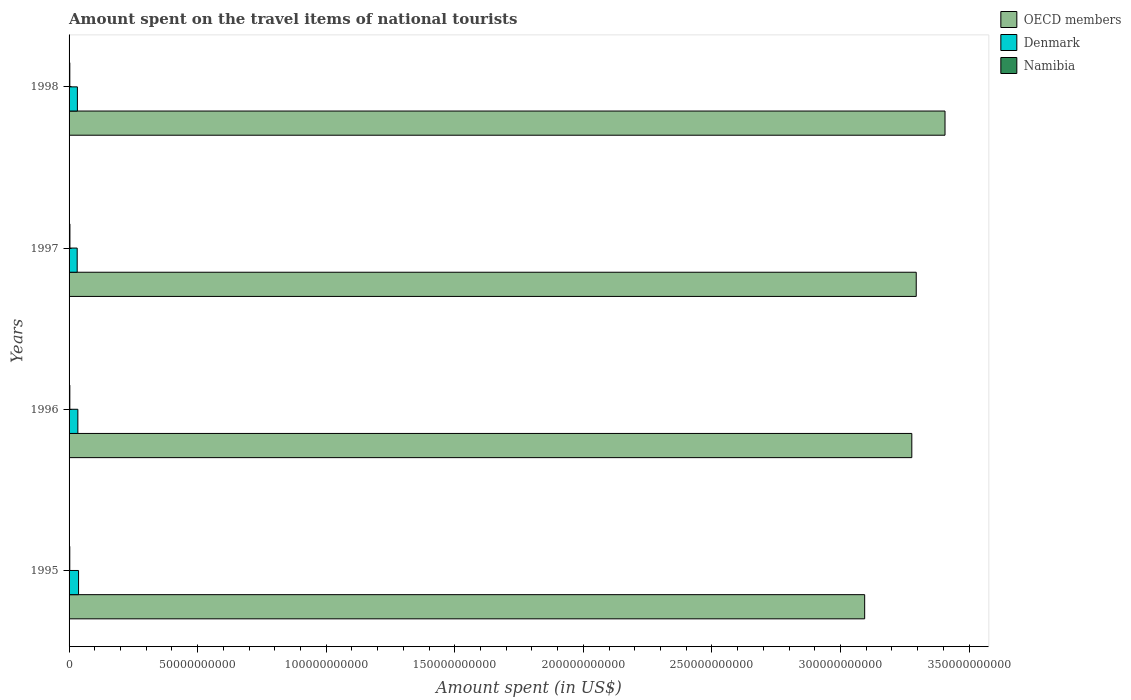How many groups of bars are there?
Your answer should be very brief. 4. What is the label of the 2nd group of bars from the top?
Provide a short and direct response. 1997. What is the amount spent on the travel items of national tourists in Namibia in 1997?
Offer a terse response. 3.33e+08. Across all years, what is the maximum amount spent on the travel items of national tourists in OECD members?
Provide a succinct answer. 3.41e+11. Across all years, what is the minimum amount spent on the travel items of national tourists in Namibia?
Offer a very short reply. 2.78e+08. In which year was the amount spent on the travel items of national tourists in Namibia maximum?
Give a very brief answer. 1997. In which year was the amount spent on the travel items of national tourists in OECD members minimum?
Provide a succinct answer. 1995. What is the total amount spent on the travel items of national tourists in Namibia in the graph?
Your answer should be compact. 1.19e+09. What is the difference between the amount spent on the travel items of national tourists in Denmark in 1996 and that in 1997?
Make the answer very short. 2.64e+08. What is the difference between the amount spent on the travel items of national tourists in OECD members in 1997 and the amount spent on the travel items of national tourists in Denmark in 1998?
Offer a terse response. 3.26e+11. What is the average amount spent on the travel items of national tourists in Denmark per year?
Provide a short and direct response. 3.38e+09. In the year 1997, what is the difference between the amount spent on the travel items of national tourists in OECD members and amount spent on the travel items of national tourists in Denmark?
Offer a terse response. 3.26e+11. In how many years, is the amount spent on the travel items of national tourists in Namibia greater than 300000000000 US$?
Offer a terse response. 0. What is the ratio of the amount spent on the travel items of national tourists in Denmark in 1996 to that in 1997?
Your answer should be compact. 1.08. Is the amount spent on the travel items of national tourists in Namibia in 1995 less than that in 1998?
Keep it short and to the point. Yes. What is the difference between the highest and the second highest amount spent on the travel items of national tourists in Denmark?
Offer a very short reply. 2.71e+08. What is the difference between the highest and the lowest amount spent on the travel items of national tourists in Namibia?
Ensure brevity in your answer.  5.50e+07. In how many years, is the amount spent on the travel items of national tourists in OECD members greater than the average amount spent on the travel items of national tourists in OECD members taken over all years?
Offer a very short reply. 3. Is the sum of the amount spent on the travel items of national tourists in OECD members in 1995 and 1998 greater than the maximum amount spent on the travel items of national tourists in Namibia across all years?
Offer a very short reply. Yes. What does the 1st bar from the bottom in 1995 represents?
Provide a short and direct response. OECD members. Is it the case that in every year, the sum of the amount spent on the travel items of national tourists in OECD members and amount spent on the travel items of national tourists in Denmark is greater than the amount spent on the travel items of national tourists in Namibia?
Your response must be concise. Yes. How many bars are there?
Your answer should be very brief. 12. How many years are there in the graph?
Make the answer very short. 4. Are the values on the major ticks of X-axis written in scientific E-notation?
Provide a short and direct response. No. Does the graph contain any zero values?
Offer a very short reply. No. Does the graph contain grids?
Give a very brief answer. No. How many legend labels are there?
Make the answer very short. 3. How are the legend labels stacked?
Offer a very short reply. Vertical. What is the title of the graph?
Your response must be concise. Amount spent on the travel items of national tourists. What is the label or title of the X-axis?
Your answer should be very brief. Amount spent (in US$). What is the Amount spent (in US$) of OECD members in 1995?
Provide a succinct answer. 3.09e+11. What is the Amount spent (in US$) of Denmark in 1995?
Provide a succinct answer. 3.69e+09. What is the Amount spent (in US$) in Namibia in 1995?
Your response must be concise. 2.78e+08. What is the Amount spent (in US$) of OECD members in 1996?
Ensure brevity in your answer.  3.28e+11. What is the Amount spent (in US$) in Denmark in 1996?
Your answer should be compact. 3.42e+09. What is the Amount spent (in US$) in Namibia in 1996?
Make the answer very short. 2.93e+08. What is the Amount spent (in US$) of OECD members in 1997?
Offer a very short reply. 3.29e+11. What is the Amount spent (in US$) in Denmark in 1997?
Your answer should be very brief. 3.16e+09. What is the Amount spent (in US$) in Namibia in 1997?
Offer a terse response. 3.33e+08. What is the Amount spent (in US$) of OECD members in 1998?
Your response must be concise. 3.41e+11. What is the Amount spent (in US$) in Denmark in 1998?
Make the answer very short. 3.24e+09. What is the Amount spent (in US$) in Namibia in 1998?
Your answer should be very brief. 2.88e+08. Across all years, what is the maximum Amount spent (in US$) in OECD members?
Offer a very short reply. 3.41e+11. Across all years, what is the maximum Amount spent (in US$) in Denmark?
Provide a short and direct response. 3.69e+09. Across all years, what is the maximum Amount spent (in US$) of Namibia?
Provide a succinct answer. 3.33e+08. Across all years, what is the minimum Amount spent (in US$) in OECD members?
Give a very brief answer. 3.09e+11. Across all years, what is the minimum Amount spent (in US$) in Denmark?
Your answer should be compact. 3.16e+09. Across all years, what is the minimum Amount spent (in US$) of Namibia?
Make the answer very short. 2.78e+08. What is the total Amount spent (in US$) in OECD members in the graph?
Keep it short and to the point. 1.31e+12. What is the total Amount spent (in US$) of Denmark in the graph?
Make the answer very short. 1.35e+1. What is the total Amount spent (in US$) of Namibia in the graph?
Your answer should be compact. 1.19e+09. What is the difference between the Amount spent (in US$) of OECD members in 1995 and that in 1996?
Offer a terse response. -1.83e+1. What is the difference between the Amount spent (in US$) of Denmark in 1995 and that in 1996?
Offer a terse response. 2.71e+08. What is the difference between the Amount spent (in US$) in Namibia in 1995 and that in 1996?
Offer a terse response. -1.50e+07. What is the difference between the Amount spent (in US$) in OECD members in 1995 and that in 1997?
Your answer should be very brief. -2.01e+1. What is the difference between the Amount spent (in US$) in Denmark in 1995 and that in 1997?
Your answer should be very brief. 5.35e+08. What is the difference between the Amount spent (in US$) in Namibia in 1995 and that in 1997?
Your answer should be compact. -5.50e+07. What is the difference between the Amount spent (in US$) in OECD members in 1995 and that in 1998?
Your answer should be very brief. -3.12e+1. What is the difference between the Amount spent (in US$) of Denmark in 1995 and that in 1998?
Your answer should be very brief. 4.55e+08. What is the difference between the Amount spent (in US$) of Namibia in 1995 and that in 1998?
Offer a terse response. -1.00e+07. What is the difference between the Amount spent (in US$) in OECD members in 1996 and that in 1997?
Keep it short and to the point. -1.72e+09. What is the difference between the Amount spent (in US$) in Denmark in 1996 and that in 1997?
Give a very brief answer. 2.64e+08. What is the difference between the Amount spent (in US$) in Namibia in 1996 and that in 1997?
Provide a succinct answer. -4.00e+07. What is the difference between the Amount spent (in US$) of OECD members in 1996 and that in 1998?
Your answer should be very brief. -1.29e+1. What is the difference between the Amount spent (in US$) in Denmark in 1996 and that in 1998?
Offer a very short reply. 1.84e+08. What is the difference between the Amount spent (in US$) of OECD members in 1997 and that in 1998?
Give a very brief answer. -1.12e+1. What is the difference between the Amount spent (in US$) of Denmark in 1997 and that in 1998?
Offer a very short reply. -8.00e+07. What is the difference between the Amount spent (in US$) of Namibia in 1997 and that in 1998?
Give a very brief answer. 4.50e+07. What is the difference between the Amount spent (in US$) in OECD members in 1995 and the Amount spent (in US$) in Denmark in 1996?
Provide a succinct answer. 3.06e+11. What is the difference between the Amount spent (in US$) in OECD members in 1995 and the Amount spent (in US$) in Namibia in 1996?
Your answer should be very brief. 3.09e+11. What is the difference between the Amount spent (in US$) in Denmark in 1995 and the Amount spent (in US$) in Namibia in 1996?
Your response must be concise. 3.40e+09. What is the difference between the Amount spent (in US$) in OECD members in 1995 and the Amount spent (in US$) in Denmark in 1997?
Your answer should be very brief. 3.06e+11. What is the difference between the Amount spent (in US$) in OECD members in 1995 and the Amount spent (in US$) in Namibia in 1997?
Keep it short and to the point. 3.09e+11. What is the difference between the Amount spent (in US$) of Denmark in 1995 and the Amount spent (in US$) of Namibia in 1997?
Ensure brevity in your answer.  3.36e+09. What is the difference between the Amount spent (in US$) of OECD members in 1995 and the Amount spent (in US$) of Denmark in 1998?
Make the answer very short. 3.06e+11. What is the difference between the Amount spent (in US$) in OECD members in 1995 and the Amount spent (in US$) in Namibia in 1998?
Provide a succinct answer. 3.09e+11. What is the difference between the Amount spent (in US$) of Denmark in 1995 and the Amount spent (in US$) of Namibia in 1998?
Provide a succinct answer. 3.40e+09. What is the difference between the Amount spent (in US$) in OECD members in 1996 and the Amount spent (in US$) in Denmark in 1997?
Your answer should be very brief. 3.25e+11. What is the difference between the Amount spent (in US$) in OECD members in 1996 and the Amount spent (in US$) in Namibia in 1997?
Provide a succinct answer. 3.27e+11. What is the difference between the Amount spent (in US$) of Denmark in 1996 and the Amount spent (in US$) of Namibia in 1997?
Make the answer very short. 3.09e+09. What is the difference between the Amount spent (in US$) in OECD members in 1996 and the Amount spent (in US$) in Denmark in 1998?
Provide a succinct answer. 3.25e+11. What is the difference between the Amount spent (in US$) in OECD members in 1996 and the Amount spent (in US$) in Namibia in 1998?
Ensure brevity in your answer.  3.27e+11. What is the difference between the Amount spent (in US$) of Denmark in 1996 and the Amount spent (in US$) of Namibia in 1998?
Provide a succinct answer. 3.13e+09. What is the difference between the Amount spent (in US$) in OECD members in 1997 and the Amount spent (in US$) in Denmark in 1998?
Ensure brevity in your answer.  3.26e+11. What is the difference between the Amount spent (in US$) in OECD members in 1997 and the Amount spent (in US$) in Namibia in 1998?
Provide a short and direct response. 3.29e+11. What is the difference between the Amount spent (in US$) of Denmark in 1997 and the Amount spent (in US$) of Namibia in 1998?
Provide a short and direct response. 2.87e+09. What is the average Amount spent (in US$) in OECD members per year?
Offer a very short reply. 3.27e+11. What is the average Amount spent (in US$) of Denmark per year?
Your answer should be very brief. 3.38e+09. What is the average Amount spent (in US$) in Namibia per year?
Give a very brief answer. 2.98e+08. In the year 1995, what is the difference between the Amount spent (in US$) of OECD members and Amount spent (in US$) of Denmark?
Provide a short and direct response. 3.06e+11. In the year 1995, what is the difference between the Amount spent (in US$) of OECD members and Amount spent (in US$) of Namibia?
Offer a very short reply. 3.09e+11. In the year 1995, what is the difference between the Amount spent (in US$) in Denmark and Amount spent (in US$) in Namibia?
Your answer should be compact. 3.41e+09. In the year 1996, what is the difference between the Amount spent (in US$) of OECD members and Amount spent (in US$) of Denmark?
Provide a short and direct response. 3.24e+11. In the year 1996, what is the difference between the Amount spent (in US$) of OECD members and Amount spent (in US$) of Namibia?
Offer a very short reply. 3.27e+11. In the year 1996, what is the difference between the Amount spent (in US$) of Denmark and Amount spent (in US$) of Namibia?
Make the answer very short. 3.13e+09. In the year 1997, what is the difference between the Amount spent (in US$) of OECD members and Amount spent (in US$) of Denmark?
Your answer should be compact. 3.26e+11. In the year 1997, what is the difference between the Amount spent (in US$) of OECD members and Amount spent (in US$) of Namibia?
Offer a very short reply. 3.29e+11. In the year 1997, what is the difference between the Amount spent (in US$) in Denmark and Amount spent (in US$) in Namibia?
Keep it short and to the point. 2.82e+09. In the year 1998, what is the difference between the Amount spent (in US$) in OECD members and Amount spent (in US$) in Denmark?
Your answer should be compact. 3.37e+11. In the year 1998, what is the difference between the Amount spent (in US$) of OECD members and Amount spent (in US$) of Namibia?
Your answer should be compact. 3.40e+11. In the year 1998, what is the difference between the Amount spent (in US$) of Denmark and Amount spent (in US$) of Namibia?
Your answer should be compact. 2.95e+09. What is the ratio of the Amount spent (in US$) in OECD members in 1995 to that in 1996?
Provide a succinct answer. 0.94. What is the ratio of the Amount spent (in US$) of Denmark in 1995 to that in 1996?
Ensure brevity in your answer.  1.08. What is the ratio of the Amount spent (in US$) in Namibia in 1995 to that in 1996?
Provide a succinct answer. 0.95. What is the ratio of the Amount spent (in US$) of OECD members in 1995 to that in 1997?
Provide a succinct answer. 0.94. What is the ratio of the Amount spent (in US$) in Denmark in 1995 to that in 1997?
Give a very brief answer. 1.17. What is the ratio of the Amount spent (in US$) of Namibia in 1995 to that in 1997?
Provide a succinct answer. 0.83. What is the ratio of the Amount spent (in US$) of OECD members in 1995 to that in 1998?
Provide a succinct answer. 0.91. What is the ratio of the Amount spent (in US$) in Denmark in 1995 to that in 1998?
Offer a terse response. 1.14. What is the ratio of the Amount spent (in US$) of Namibia in 1995 to that in 1998?
Offer a terse response. 0.97. What is the ratio of the Amount spent (in US$) in Denmark in 1996 to that in 1997?
Keep it short and to the point. 1.08. What is the ratio of the Amount spent (in US$) of Namibia in 1996 to that in 1997?
Keep it short and to the point. 0.88. What is the ratio of the Amount spent (in US$) of OECD members in 1996 to that in 1998?
Provide a succinct answer. 0.96. What is the ratio of the Amount spent (in US$) in Denmark in 1996 to that in 1998?
Provide a succinct answer. 1.06. What is the ratio of the Amount spent (in US$) of Namibia in 1996 to that in 1998?
Keep it short and to the point. 1.02. What is the ratio of the Amount spent (in US$) in OECD members in 1997 to that in 1998?
Provide a succinct answer. 0.97. What is the ratio of the Amount spent (in US$) of Denmark in 1997 to that in 1998?
Give a very brief answer. 0.98. What is the ratio of the Amount spent (in US$) of Namibia in 1997 to that in 1998?
Ensure brevity in your answer.  1.16. What is the difference between the highest and the second highest Amount spent (in US$) in OECD members?
Offer a very short reply. 1.12e+1. What is the difference between the highest and the second highest Amount spent (in US$) of Denmark?
Ensure brevity in your answer.  2.71e+08. What is the difference between the highest and the second highest Amount spent (in US$) in Namibia?
Ensure brevity in your answer.  4.00e+07. What is the difference between the highest and the lowest Amount spent (in US$) in OECD members?
Your answer should be very brief. 3.12e+1. What is the difference between the highest and the lowest Amount spent (in US$) of Denmark?
Give a very brief answer. 5.35e+08. What is the difference between the highest and the lowest Amount spent (in US$) in Namibia?
Offer a terse response. 5.50e+07. 